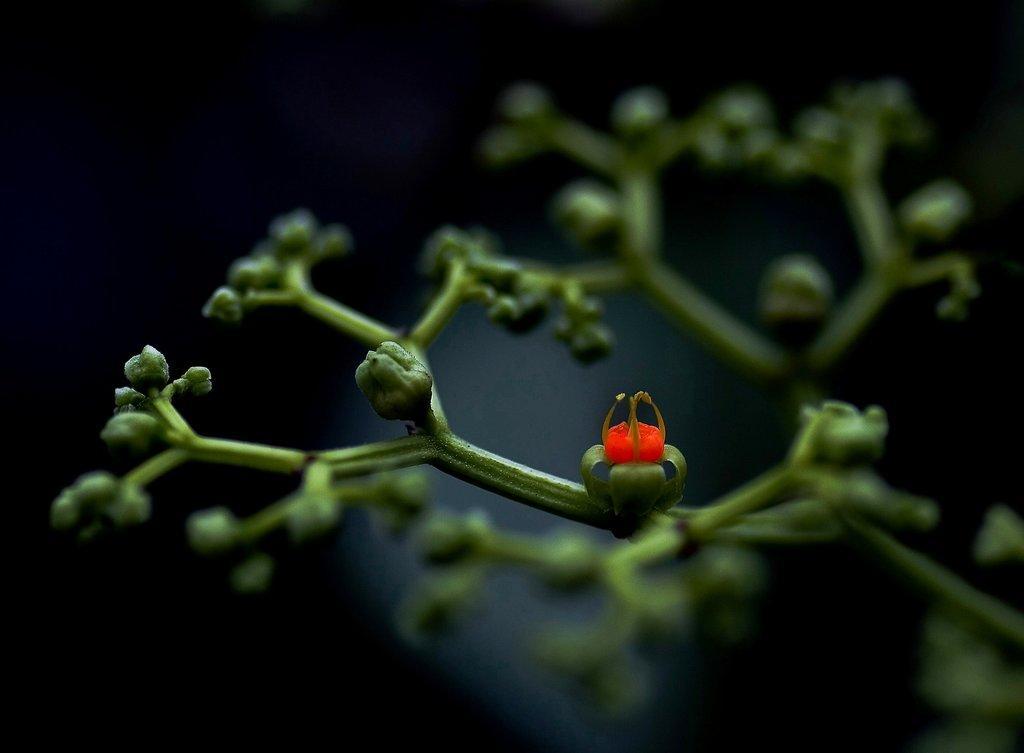Can you describe this image briefly? In this image we can see a flower and buds. And the dark background. 